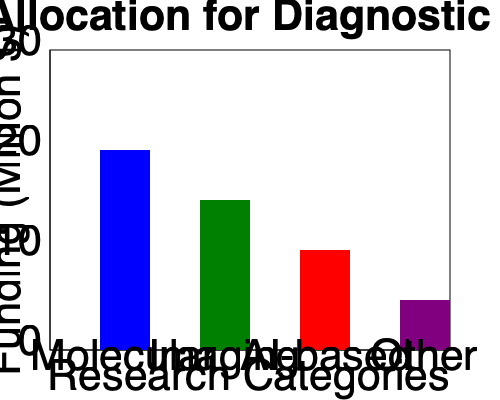Based on the bar chart, which type of diagnostic research receives the highest funding, and what percentage of the total funding does it represent? To answer this question, we need to follow these steps:

1. Identify the highest bar in the chart:
   The blue bar representing "Molecular" research is the tallest.

2. Calculate the funding amount for Molecular research:
   The Molecular bar reaches the 20 million mark on the y-axis.

3. Calculate the total funding across all categories:
   Molecular: $20 million
   Imaging: $15 million
   AI-based: $10 million
   Other: $5 million
   Total: $20 + $15 + $10 + $5 = $50 million

4. Calculate the percentage of funding for Molecular research:
   Percentage = (Funding for Molecular / Total Funding) × 100
   = ($20 million / $50 million) × 100
   = 0.4 × 100 = 40%

Therefore, Molecular diagnostic research receives the highest funding, representing 40% of the total funding allocation.
Answer: Molecular, 40% 